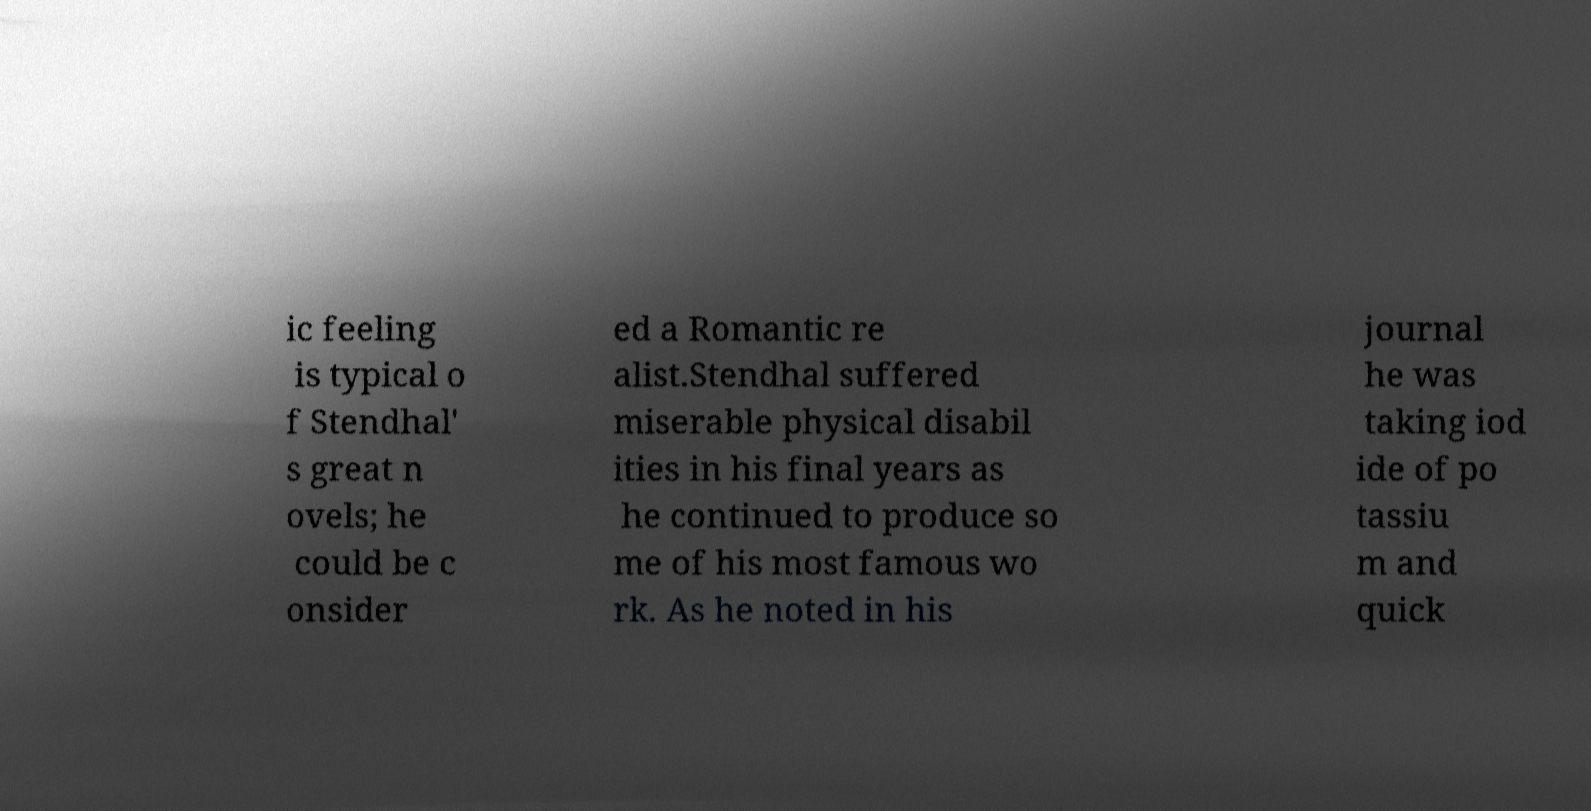There's text embedded in this image that I need extracted. Can you transcribe it verbatim? ic feeling is typical o f Stendhal' s great n ovels; he could be c onsider ed a Romantic re alist.Stendhal suffered miserable physical disabil ities in his final years as he continued to produce so me of his most famous wo rk. As he noted in his journal he was taking iod ide of po tassiu m and quick 